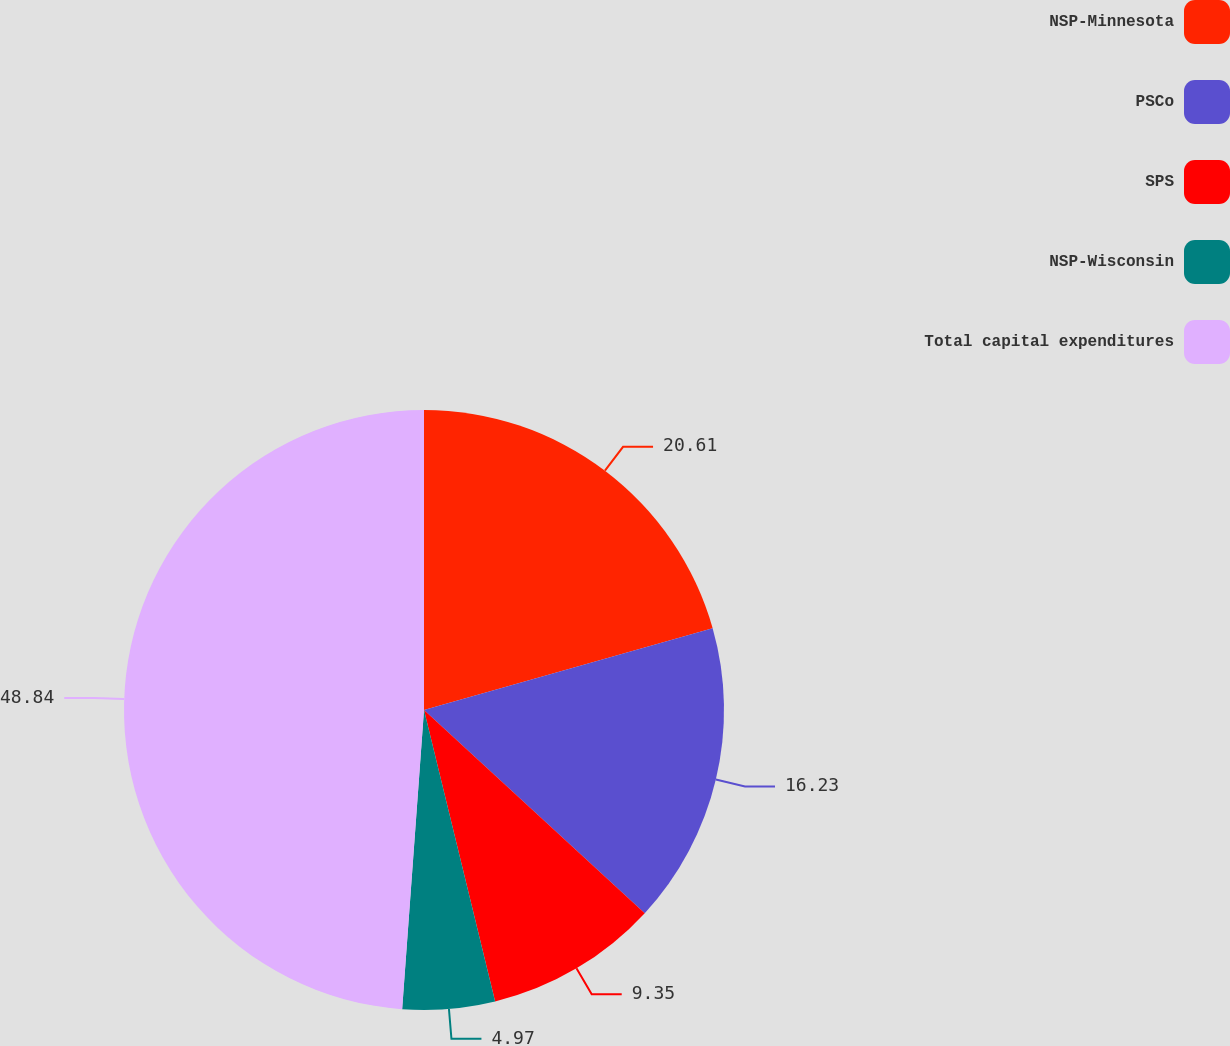<chart> <loc_0><loc_0><loc_500><loc_500><pie_chart><fcel>NSP-Minnesota<fcel>PSCo<fcel>SPS<fcel>NSP-Wisconsin<fcel>Total capital expenditures<nl><fcel>20.61%<fcel>16.23%<fcel>9.35%<fcel>4.97%<fcel>48.84%<nl></chart> 